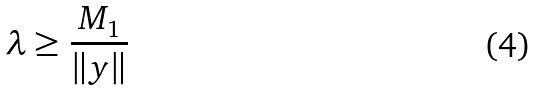<formula> <loc_0><loc_0><loc_500><loc_500>\lambda \geq \frac { M _ { 1 } } { \| y \| }</formula> 